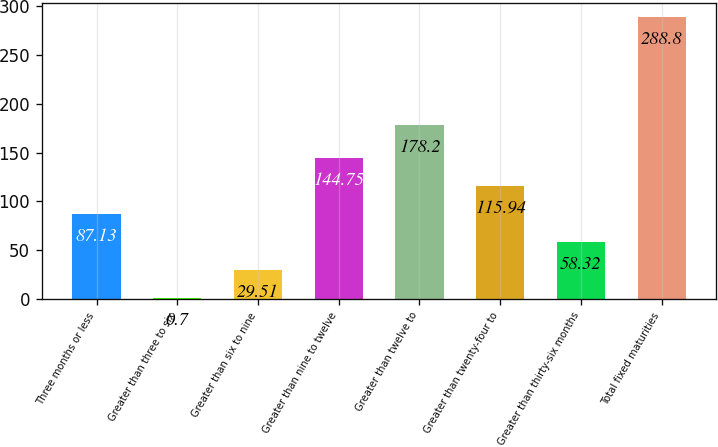<chart> <loc_0><loc_0><loc_500><loc_500><bar_chart><fcel>Three months or less<fcel>Greater than three to six<fcel>Greater than six to nine<fcel>Greater than nine to twelve<fcel>Greater than twelve to<fcel>Greater than twenty-four to<fcel>Greater than thirty-six months<fcel>Total fixed maturities<nl><fcel>87.13<fcel>0.7<fcel>29.51<fcel>144.75<fcel>178.2<fcel>115.94<fcel>58.32<fcel>288.8<nl></chart> 